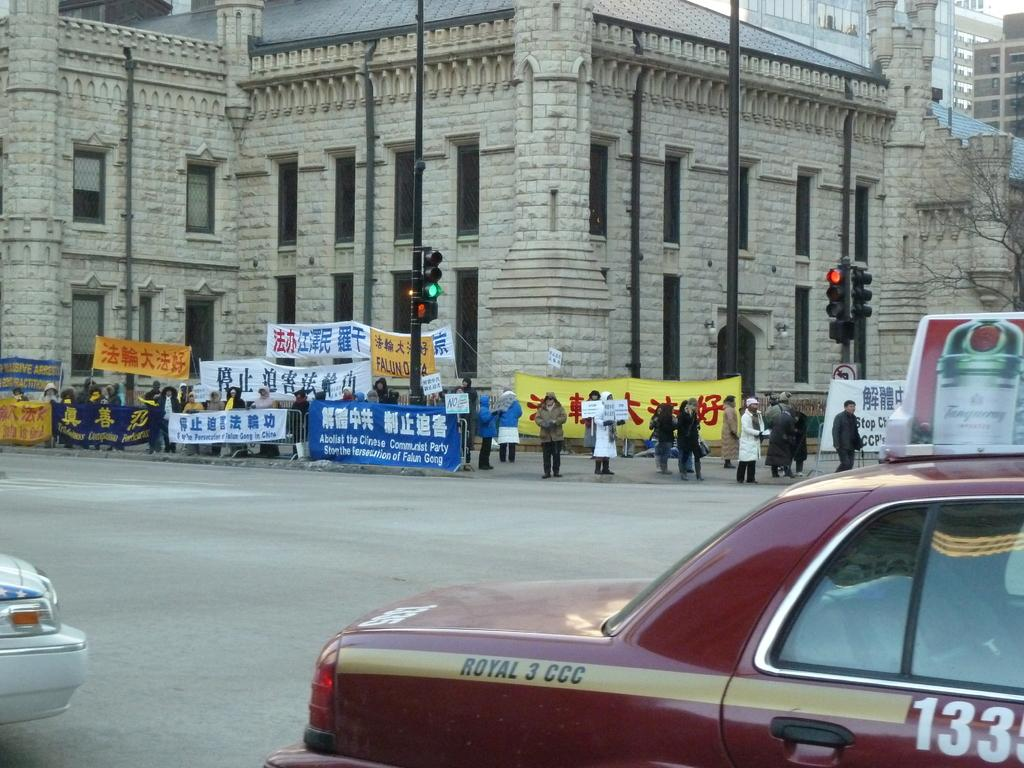<image>
Offer a succinct explanation of the picture presented. People holding signs that say abolish the Chinese Communist party written in english and chinese. 